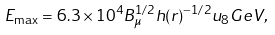<formula> <loc_0><loc_0><loc_500><loc_500>E _ { \max } = 6 . 3 \times 1 0 ^ { 4 } B _ { \mu } ^ { 1 / 2 } h ( r ) ^ { - 1 / 2 } u _ { 8 } G e V ,</formula> 